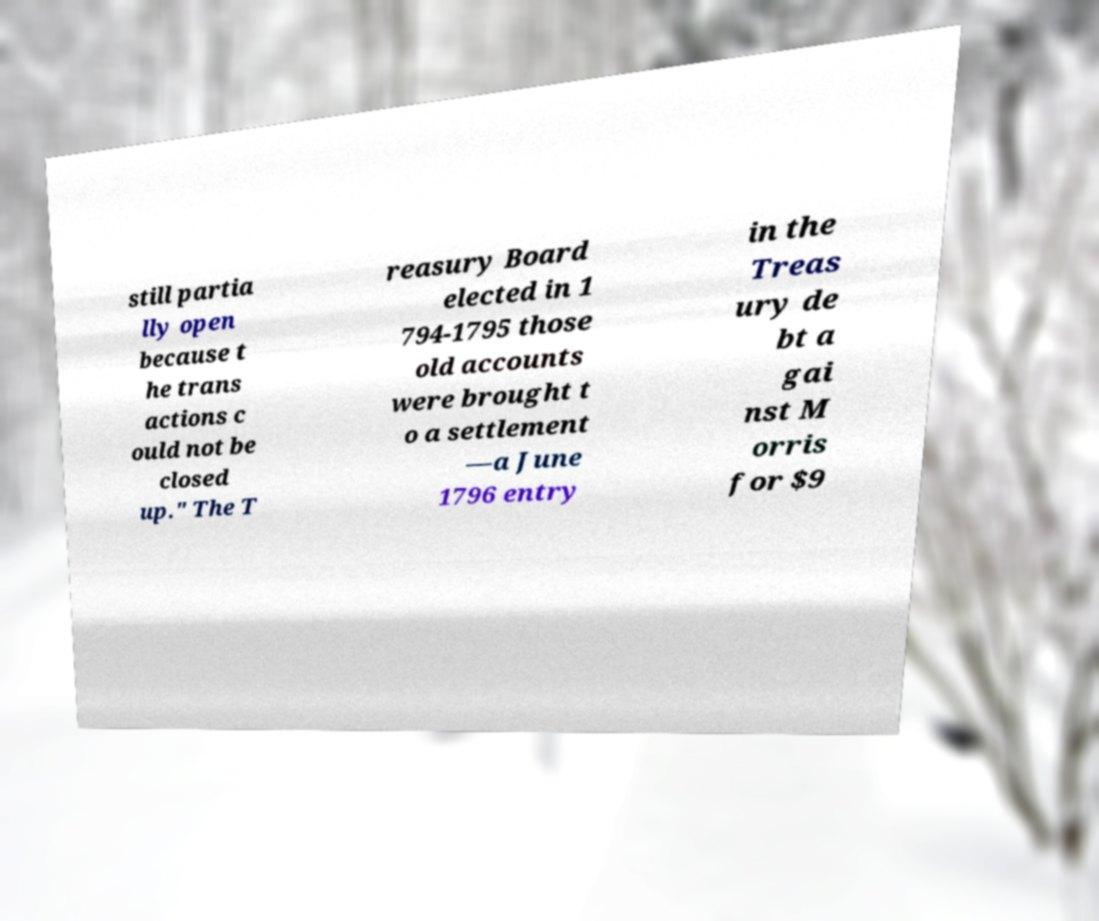I need the written content from this picture converted into text. Can you do that? still partia lly open because t he trans actions c ould not be closed up." The T reasury Board elected in 1 794-1795 those old accounts were brought t o a settlement —a June 1796 entry in the Treas ury de bt a gai nst M orris for $9 